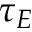Convert formula to latex. <formula><loc_0><loc_0><loc_500><loc_500>\tau _ { E }</formula> 